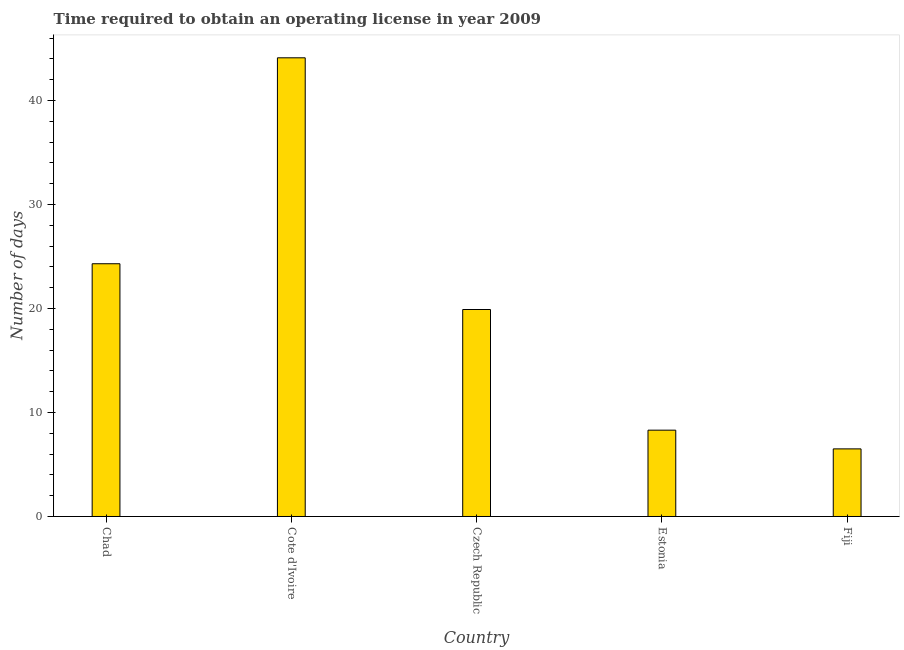Does the graph contain any zero values?
Your answer should be very brief. No. What is the title of the graph?
Provide a succinct answer. Time required to obtain an operating license in year 2009. What is the label or title of the X-axis?
Offer a very short reply. Country. What is the label or title of the Y-axis?
Give a very brief answer. Number of days. What is the number of days to obtain operating license in Chad?
Make the answer very short. 24.3. Across all countries, what is the maximum number of days to obtain operating license?
Offer a terse response. 44.1. In which country was the number of days to obtain operating license maximum?
Give a very brief answer. Cote d'Ivoire. In which country was the number of days to obtain operating license minimum?
Make the answer very short. Fiji. What is the sum of the number of days to obtain operating license?
Your answer should be very brief. 103.1. What is the difference between the number of days to obtain operating license in Chad and Cote d'Ivoire?
Keep it short and to the point. -19.8. What is the average number of days to obtain operating license per country?
Your response must be concise. 20.62. What is the ratio of the number of days to obtain operating license in Cote d'Ivoire to that in Estonia?
Offer a terse response. 5.31. Is the number of days to obtain operating license in Cote d'Ivoire less than that in Fiji?
Your response must be concise. No. What is the difference between the highest and the second highest number of days to obtain operating license?
Your response must be concise. 19.8. What is the difference between the highest and the lowest number of days to obtain operating license?
Give a very brief answer. 37.6. In how many countries, is the number of days to obtain operating license greater than the average number of days to obtain operating license taken over all countries?
Ensure brevity in your answer.  2. How many countries are there in the graph?
Keep it short and to the point. 5. What is the difference between two consecutive major ticks on the Y-axis?
Your answer should be very brief. 10. Are the values on the major ticks of Y-axis written in scientific E-notation?
Your response must be concise. No. What is the Number of days in Chad?
Your response must be concise. 24.3. What is the Number of days in Cote d'Ivoire?
Your answer should be compact. 44.1. What is the Number of days in Czech Republic?
Provide a short and direct response. 19.9. What is the Number of days in Fiji?
Ensure brevity in your answer.  6.5. What is the difference between the Number of days in Chad and Cote d'Ivoire?
Keep it short and to the point. -19.8. What is the difference between the Number of days in Cote d'Ivoire and Czech Republic?
Offer a terse response. 24.2. What is the difference between the Number of days in Cote d'Ivoire and Estonia?
Provide a succinct answer. 35.8. What is the difference between the Number of days in Cote d'Ivoire and Fiji?
Provide a succinct answer. 37.6. What is the ratio of the Number of days in Chad to that in Cote d'Ivoire?
Offer a terse response. 0.55. What is the ratio of the Number of days in Chad to that in Czech Republic?
Ensure brevity in your answer.  1.22. What is the ratio of the Number of days in Chad to that in Estonia?
Your answer should be very brief. 2.93. What is the ratio of the Number of days in Chad to that in Fiji?
Ensure brevity in your answer.  3.74. What is the ratio of the Number of days in Cote d'Ivoire to that in Czech Republic?
Your answer should be compact. 2.22. What is the ratio of the Number of days in Cote d'Ivoire to that in Estonia?
Provide a short and direct response. 5.31. What is the ratio of the Number of days in Cote d'Ivoire to that in Fiji?
Provide a succinct answer. 6.79. What is the ratio of the Number of days in Czech Republic to that in Estonia?
Give a very brief answer. 2.4. What is the ratio of the Number of days in Czech Republic to that in Fiji?
Your answer should be compact. 3.06. What is the ratio of the Number of days in Estonia to that in Fiji?
Provide a succinct answer. 1.28. 